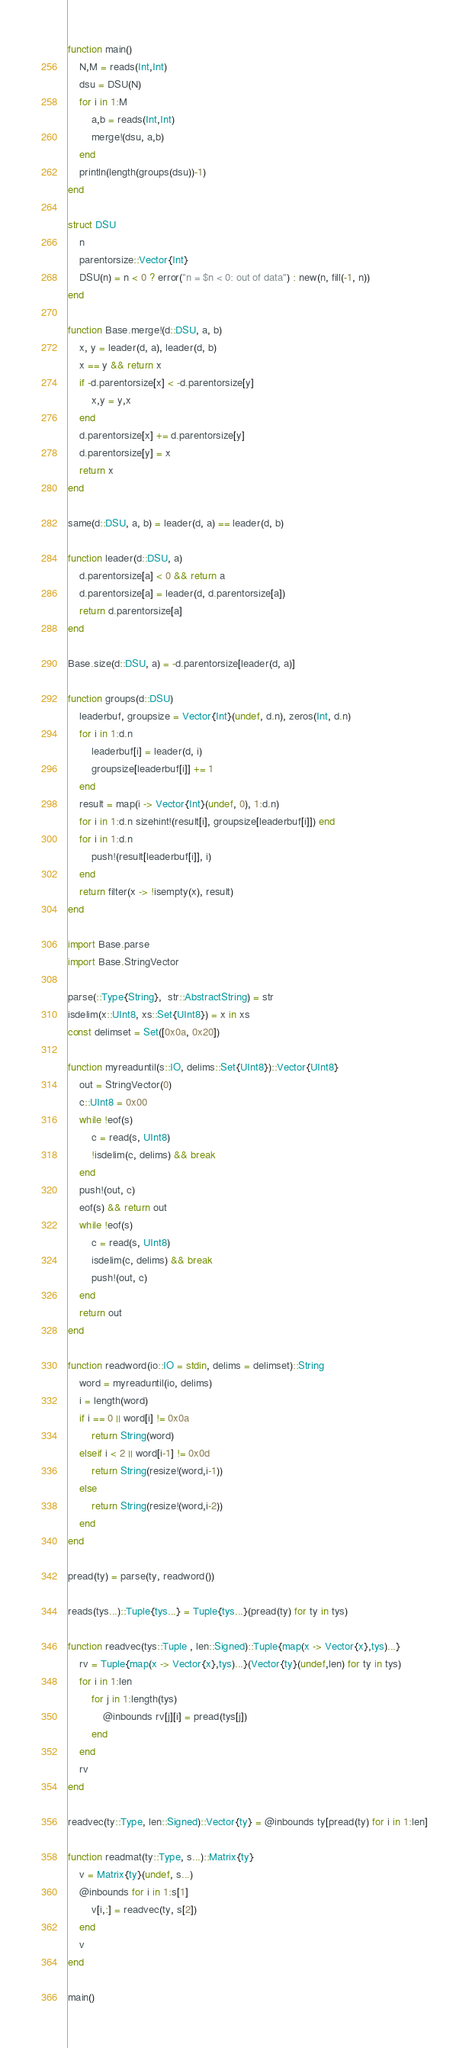<code> <loc_0><loc_0><loc_500><loc_500><_Julia_>function main()
    N,M = reads(Int,Int)
    dsu = DSU(N)
    for i in 1:M
        a,b = reads(Int,Int)
        merge!(dsu, a,b)
    end
    println(length(groups(dsu))-1)
end

struct DSU
    n
    parentorsize::Vector{Int}
    DSU(n) = n < 0 ? error("n = $n < 0: out of data") : new(n, fill(-1, n))
end

function Base.merge!(d::DSU, a, b)
    x, y = leader(d, a), leader(d, b)
    x == y && return x
    if -d.parentorsize[x] < -d.parentorsize[y]
        x,y = y,x
    end
    d.parentorsize[x] += d.parentorsize[y]
    d.parentorsize[y] = x
    return x
end

same(d::DSU, a, b) = leader(d, a) == leader(d, b)

function leader(d::DSU, a)
    d.parentorsize[a] < 0 && return a
    d.parentorsize[a] = leader(d, d.parentorsize[a])
    return d.parentorsize[a]
end

Base.size(d::DSU, a) = -d.parentorsize[leader(d, a)]

function groups(d::DSU)
    leaderbuf, groupsize = Vector{Int}(undef, d.n), zeros(Int, d.n)
    for i in 1:d.n
        leaderbuf[i] = leader(d, i)
        groupsize[leaderbuf[i]] += 1
    end
    result = map(i -> Vector{Int}(undef, 0), 1:d.n)
    for i in 1:d.n sizehint!(result[i], groupsize[leaderbuf[i]]) end
    for i in 1:d.n
        push!(result[leaderbuf[i]], i)
    end
    return filter(x -> !isempty(x), result)
end

import Base.parse
import Base.StringVector

parse(::Type{String},  str::AbstractString) = str
isdelim(x::UInt8, xs::Set{UInt8}) = x in xs
const delimset = Set([0x0a, 0x20])

function myreaduntil(s::IO, delims::Set{UInt8})::Vector{UInt8}
    out = StringVector(0)
    c::UInt8 = 0x00
    while !eof(s)
        c = read(s, UInt8)
        !isdelim(c, delims) && break
    end
    push!(out, c)
    eof(s) && return out
    while !eof(s)
        c = read(s, UInt8)
        isdelim(c, delims) && break
        push!(out, c)
    end
    return out
end

function readword(io::IO = stdin, delims = delimset)::String
    word = myreaduntil(io, delims)
    i = length(word)
    if i == 0 || word[i] != 0x0a
        return String(word)
    elseif i < 2 || word[i-1] != 0x0d
        return String(resize!(word,i-1))
    else
        return String(resize!(word,i-2))
    end
end

pread(ty) = parse(ty, readword())

reads(tys...)::Tuple{tys...} = Tuple{tys...}(pread(ty) for ty in tys)

function readvec(tys::Tuple , len::Signed)::Tuple{map(x -> Vector{x},tys)...}
    rv = Tuple{map(x -> Vector{x},tys)...}(Vector{ty}(undef,len) for ty in tys)
    for i in 1:len
        for j in 1:length(tys)
            @inbounds rv[j][i] = pread(tys[j])
        end
    end
    rv
end

readvec(ty::Type, len::Signed)::Vector{ty} = @inbounds ty[pread(ty) for i in 1:len]

function readmat(ty::Type, s...)::Matrix{ty}
    v = Matrix{ty}(undef, s...)
    @inbounds for i in 1:s[1]
        v[i,:] = readvec(ty, s[2])
    end
    v
end

main()
</code> 